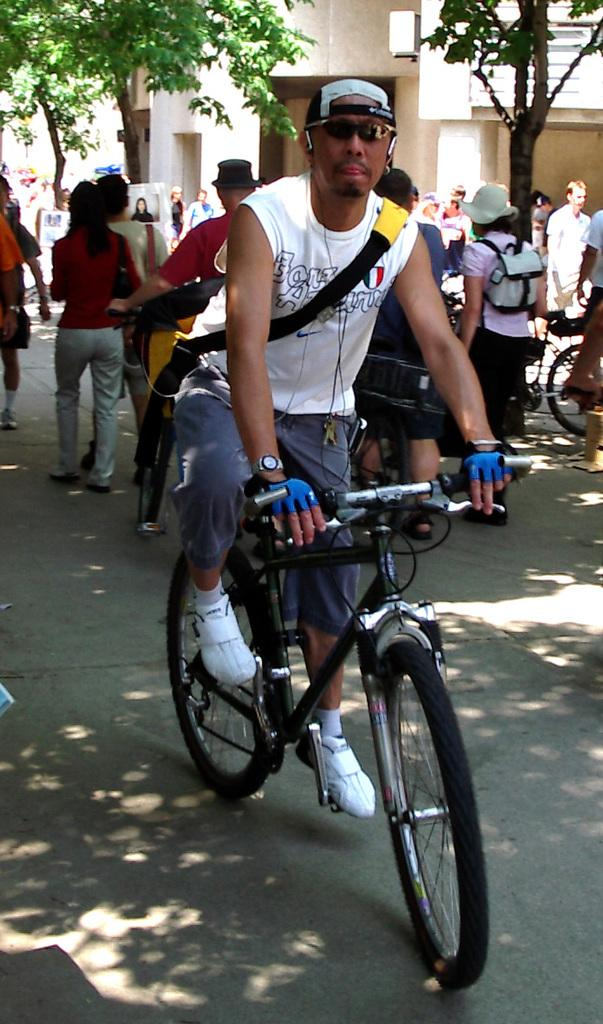What is the man in the image wearing? The man is wearing goggles and a cap. What is the man doing in the image? The man is sitting on a bicycle. What are most people in the image doing? Most people in the image are standing or walking. What is the woman in the image wearing? The woman is wearing a bag and a hat. What can be seen in the background of the image? There are trees in front of a building. What type of cave can be seen in the image? There is no cave present in the image. How many twigs are visible in the image? There is no mention of twigs in the image, so it is impossible to determine their number. 